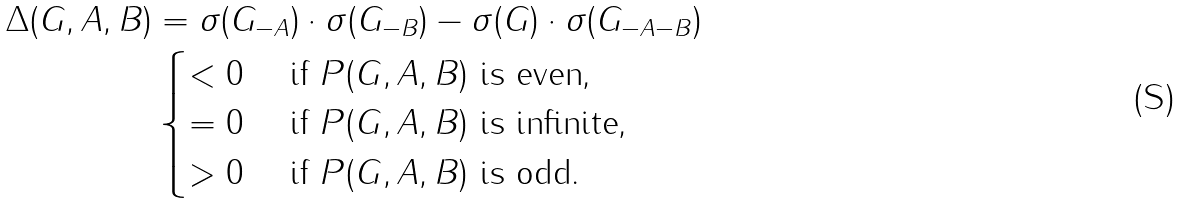Convert formula to latex. <formula><loc_0><loc_0><loc_500><loc_500>\Delta ( G , A , B ) & = \sigma ( G _ { - A } ) \cdot \sigma ( G _ { - B } ) - \sigma ( G ) \cdot \sigma ( G _ { - A - B } ) \\ & \begin{cases} < 0 & \text { if } P ( G , A , B ) \text { is even,} \\ = 0 & \text { if } P ( G , A , B ) \text { is infinite,} \\ > 0 & \text { if } P ( G , A , B ) \text { is odd.} \end{cases}</formula> 